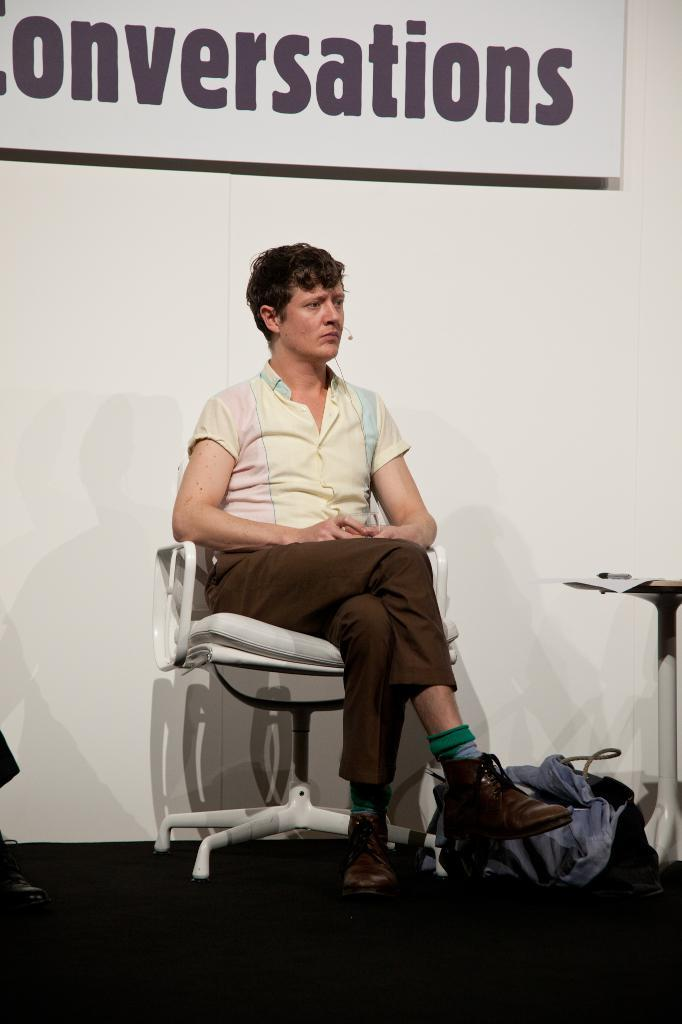What is the person in the image doing? The person is sitting on a chair. What can be seen on the surface near the chair? There is a bag and cloth on the surface near the chair. What is on the table in the image? There is a paper on the table. What is visible in the background of the image? There is a banner and a white wall in the background. What type of cracker is hanging from the hook in the image? There is no cracker or hook present in the image. What is the person in the image using to lead the group? There is no indication in the image that the person is leading a group or using any specific object to do so. 